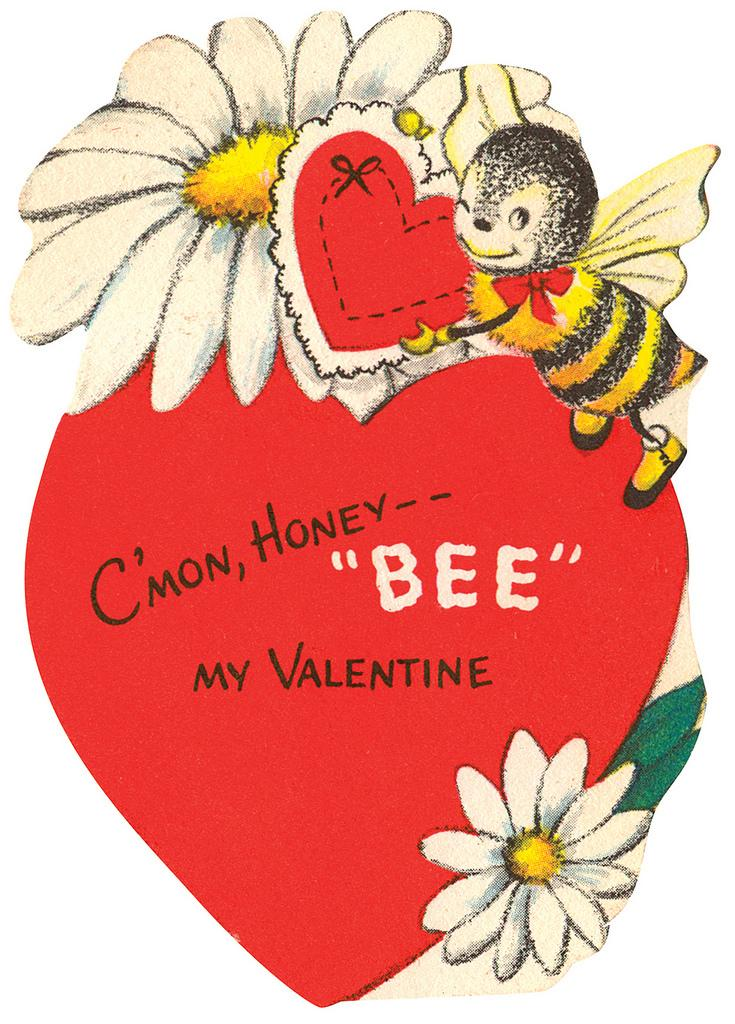What type of image can be seen in the picture? There is a picture of a heart in the image. What other images are present in the picture? There is a picture of a flower and a picture of an insect in the image. What type of fowl can be seen in the image? There is no fowl present in the image; it only contains pictures of a heart, a flower, and an insect. 